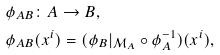Convert formula to latex. <formula><loc_0><loc_0><loc_500><loc_500>& \phi _ { A B } \colon A \to B , \\ & \phi _ { A B } ( x ^ { i } ) = ( \phi _ { B } | _ { \mathcal { M } _ { A } } \circ \phi _ { A } ^ { - 1 } ) ( x ^ { i } ) ,</formula> 